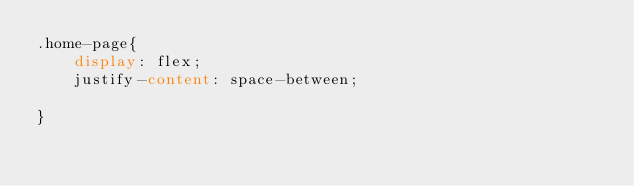Convert code to text. <code><loc_0><loc_0><loc_500><loc_500><_CSS_>.home-page{
    display: flex;
    justify-content: space-between;
    
}</code> 